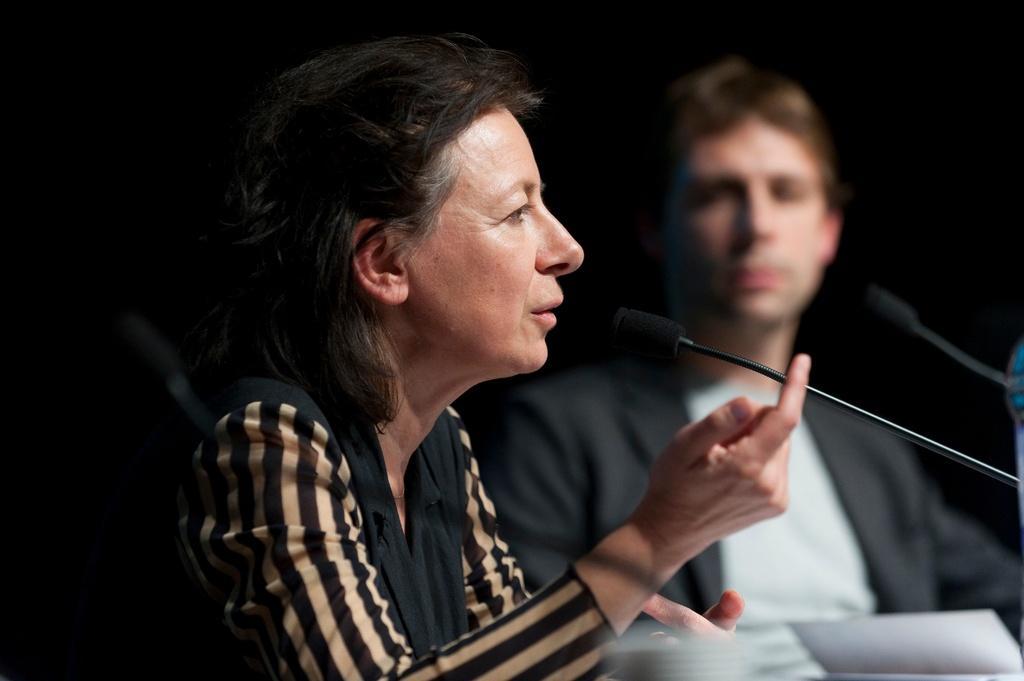Could you give a brief overview of what you see in this image? In the center of the image, we can see a man and a lady and there are mics. At the bottom, there are papers. 